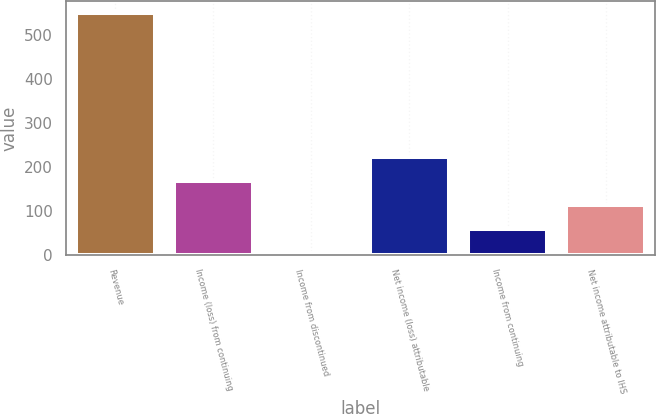Convert chart. <chart><loc_0><loc_0><loc_500><loc_500><bar_chart><fcel>Revenue<fcel>Income (loss) from continuing<fcel>Income from discontinued<fcel>Net income (loss) attributable<fcel>Income from continuing<fcel>Net income attributable to IHS<nl><fcel>548.5<fcel>167.21<fcel>3.8<fcel>221.68<fcel>58.27<fcel>112.74<nl></chart> 